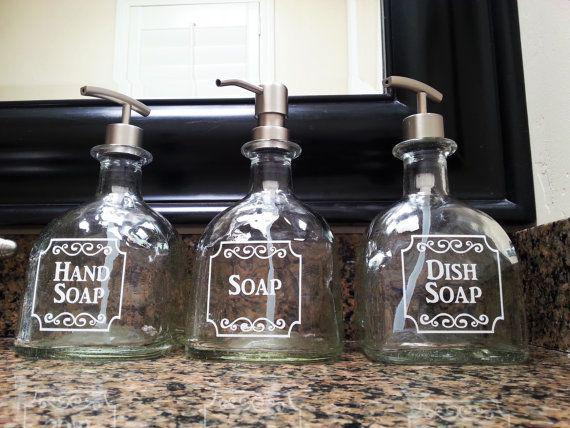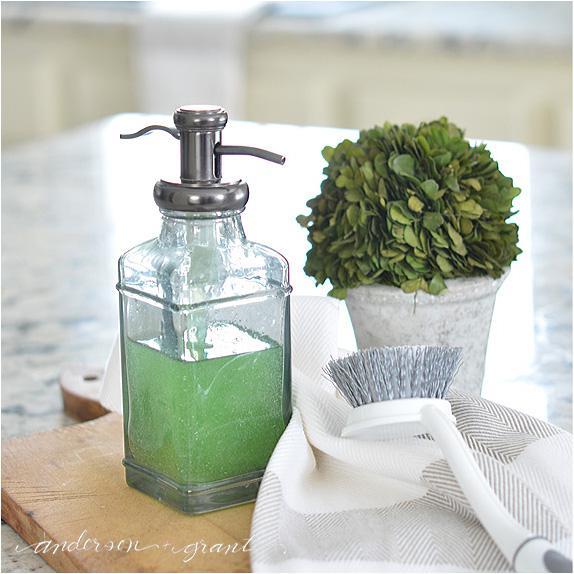The first image is the image on the left, the second image is the image on the right. Assess this claim about the two images: "A lone dispenser has some green soap in it.". Correct or not? Answer yes or no. Yes. 